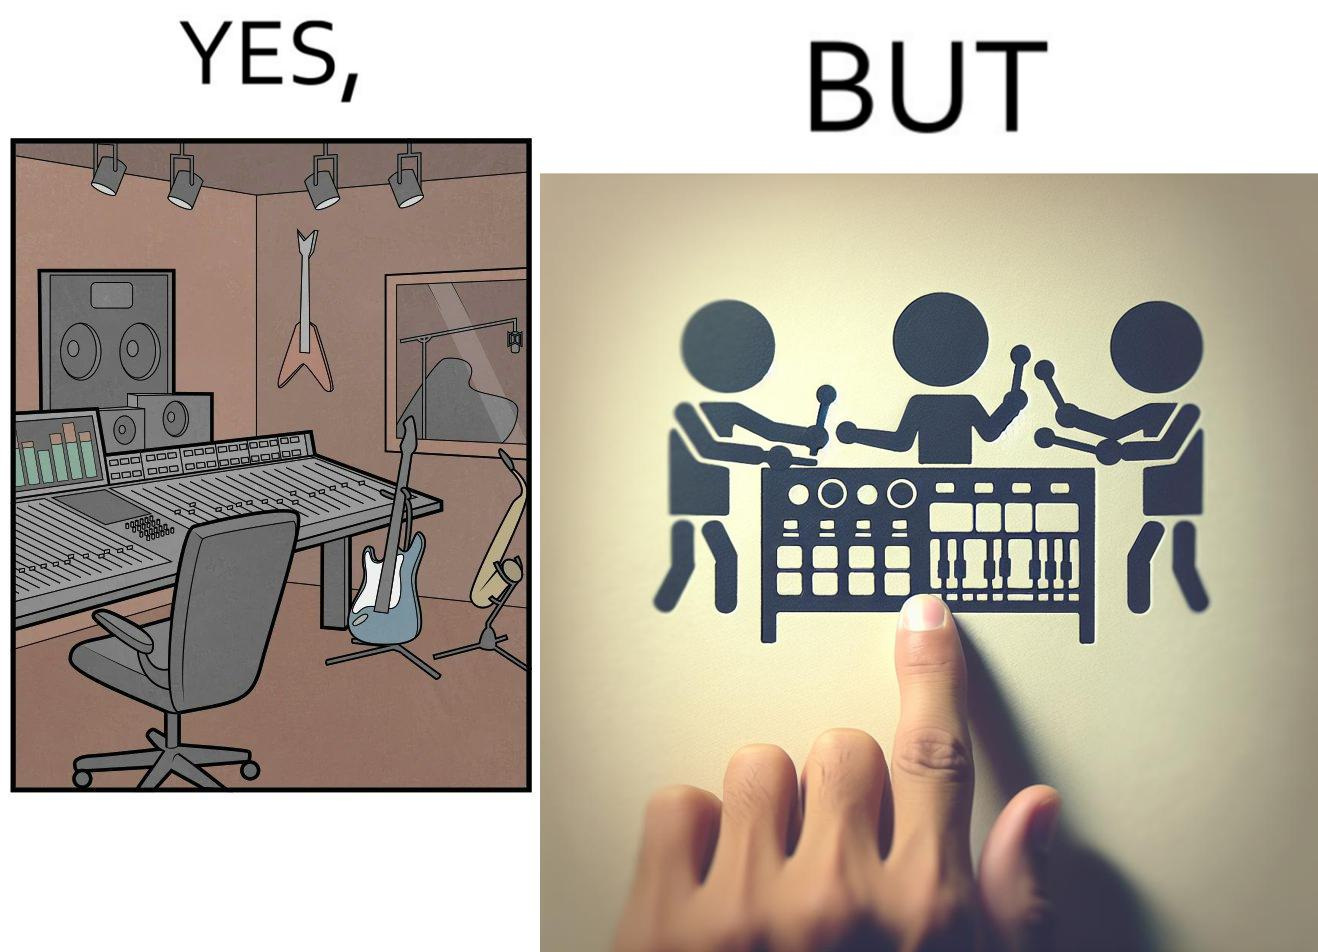Is there satirical content in this image? Yes, this image is satirical. 